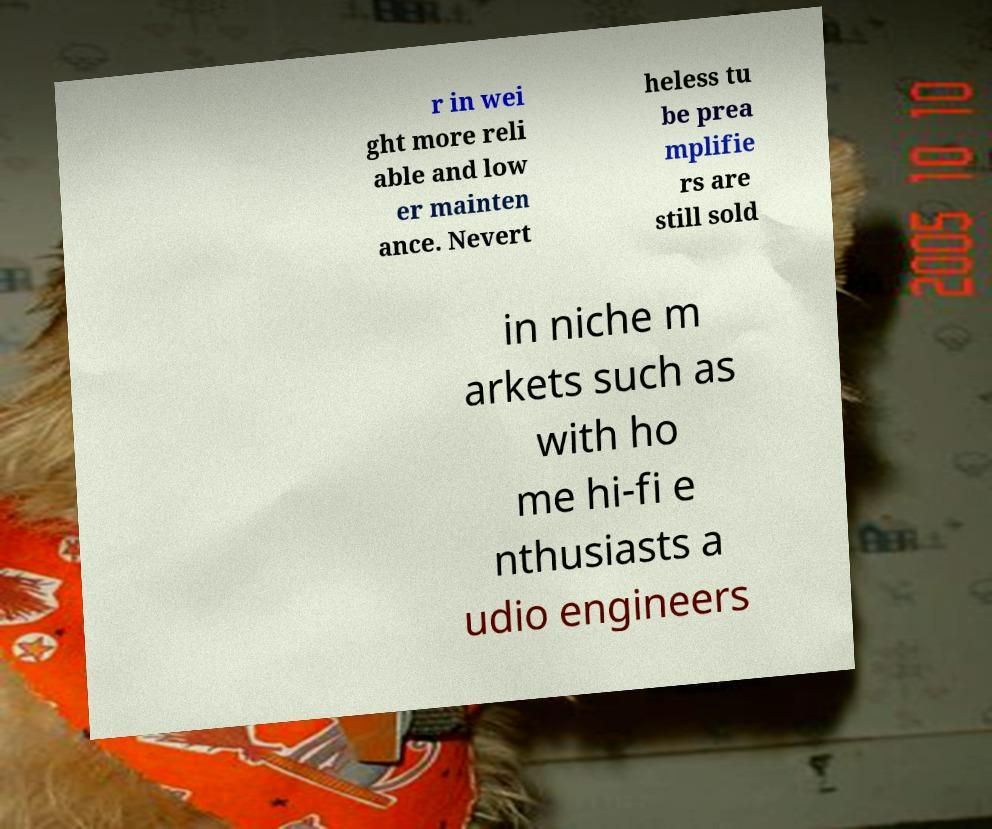Can you accurately transcribe the text from the provided image for me? r in wei ght more reli able and low er mainten ance. Nevert heless tu be prea mplifie rs are still sold in niche m arkets such as with ho me hi-fi e nthusiasts a udio engineers 